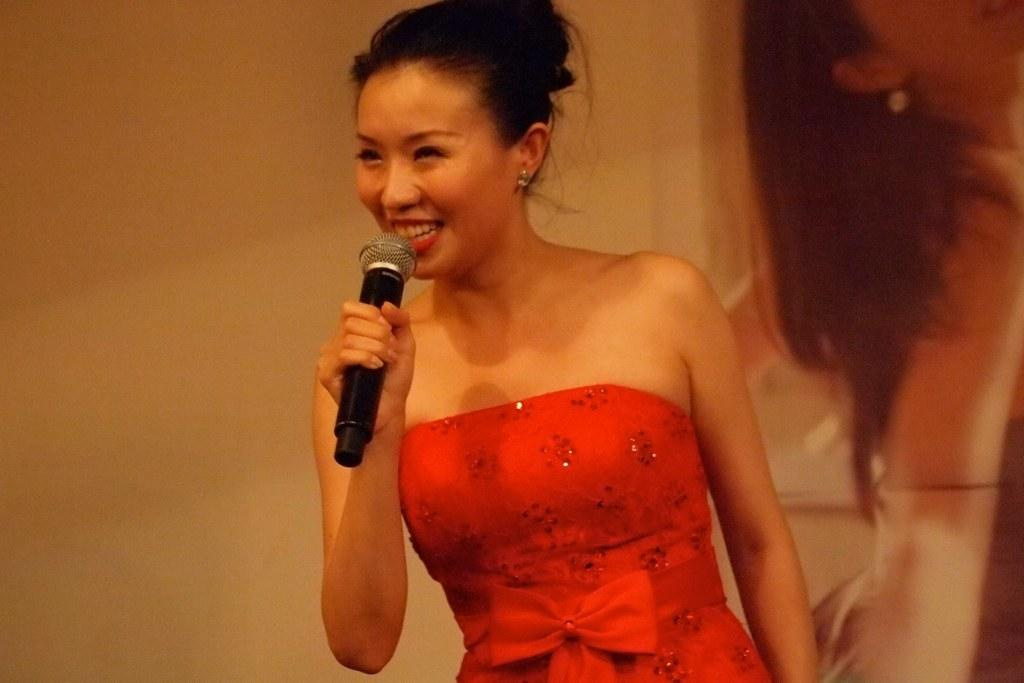Who is the main subject in the image? There is a woman in the image. What is the woman wearing? The woman is wearing an orange dress. What is the woman holding in the image? The woman is holding a mic. What is the woman doing in the image? The woman is speaking. What can be seen in the background of the image? There is a wall in the background of the image. Can you see any fairies or kittens in the image? No, there are no fairies or kittens present in the image. What news is the woman sharing in the image? The image does not provide any information about the news being shared by the woman. 